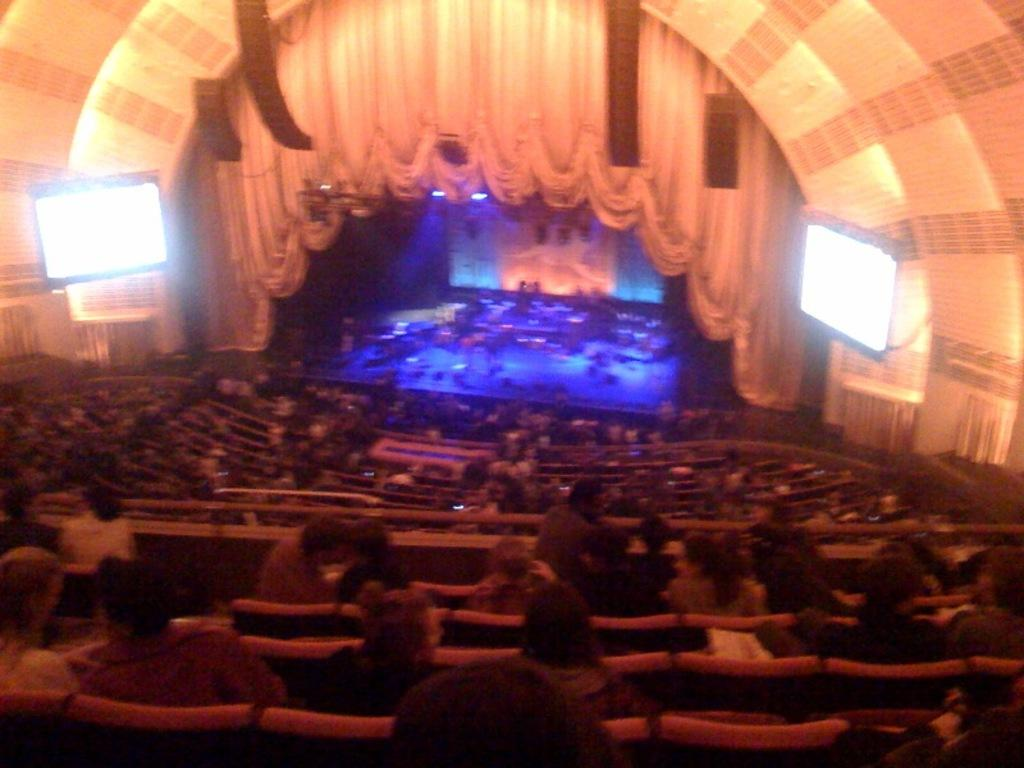What type of venue is shown in the image? The image depicts an auditorium. What are the people in the image doing? There are people seated in the auditorium. What is in front of the seated people? There are screens in front of the seated people. What can be seen in the auditorium that provides illumination? Lights are present in the auditorium. What type of decorative element is visible in the auditorium? Curtains are visible in the auditorium. What type of food is the actor biting into during the performance in the image? There is no actor or food present in the image; it depicts an auditorium with people seated and screens in front of them. Can you tell me how many tramps are visible in the image? There are no tramps present in the image. 